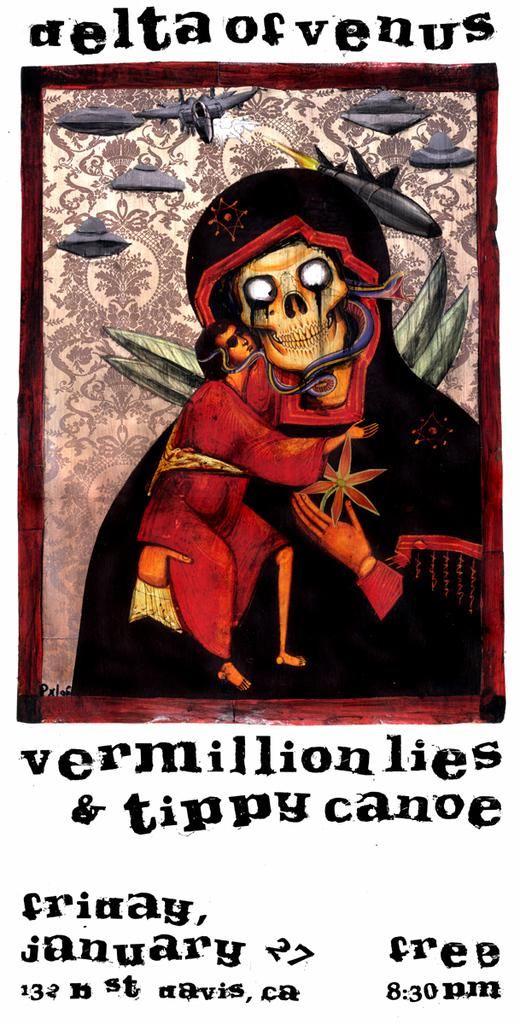<image>
Give a short and clear explanation of the subsequent image. a skull poster with the words Delta of Venus written above it 